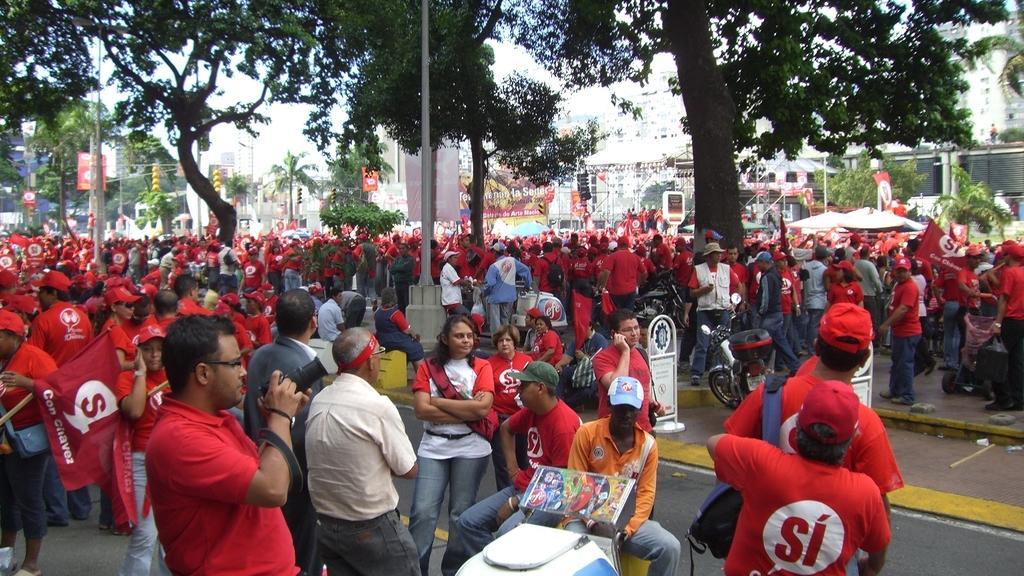Please provide a concise description of this image. Here in this picture we can see number of people standing and walking on the road over there and we can see most of them are wearing red colored t shirts on them and wearing caps on them and the person in the front is holding a camera in his hand and we can see trees and plants present all over there and in the far we can see buildings present here and there. 